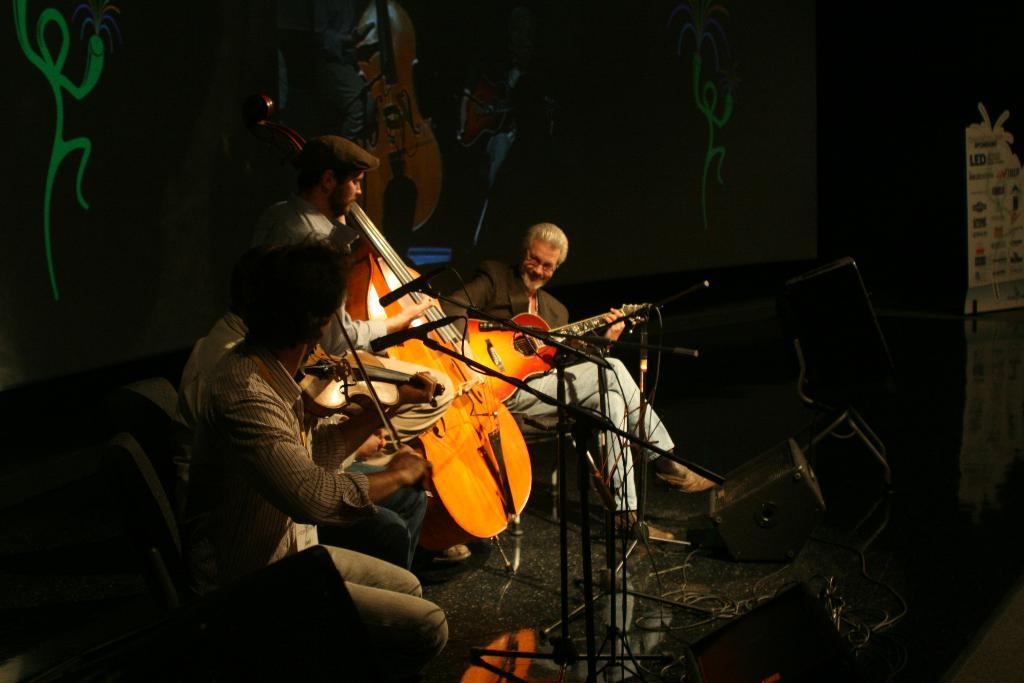How many people are in the image? There are three people in the image. What are the people doing in the image? The people are playing musical instruments. What is the boy's name in the image? There is no boy mentioned or depicted in the image, so we cannot determine the name of a boy. 